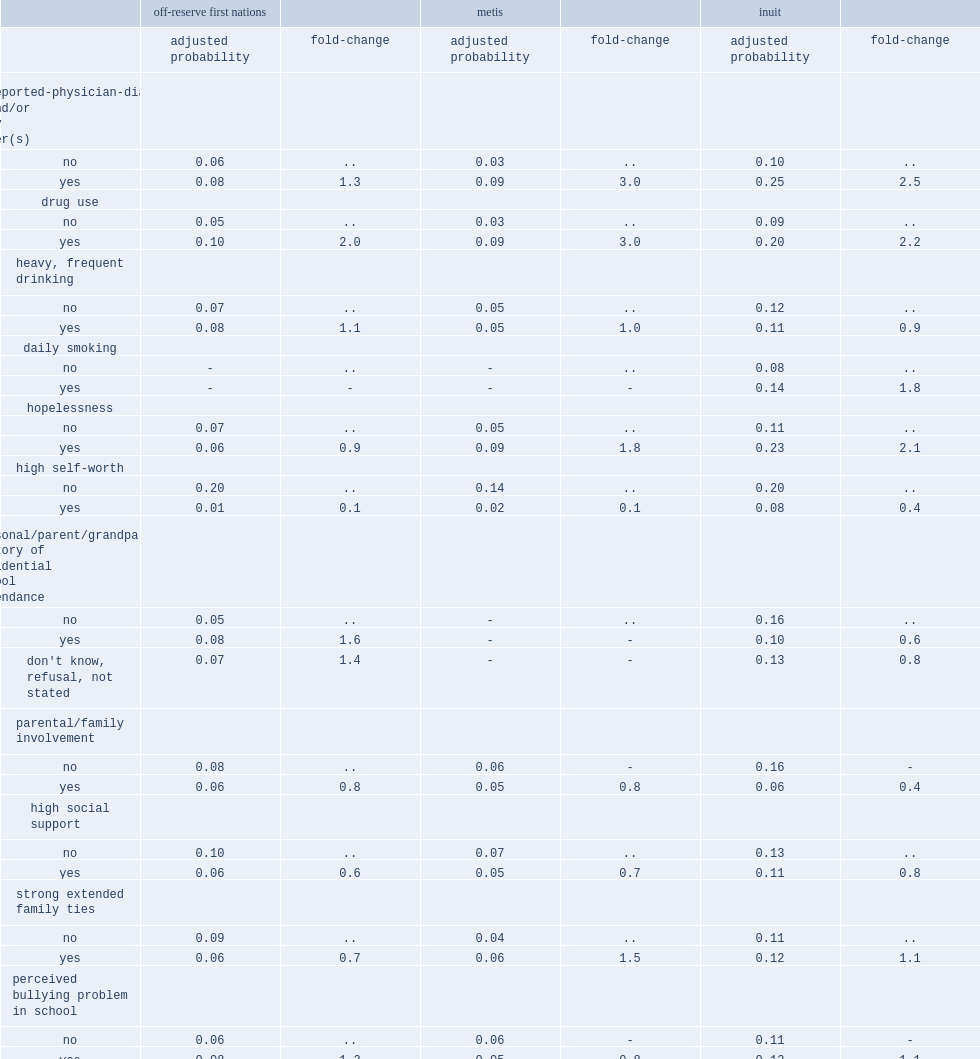What was the multiple relationship between metis who reported mood and/or anxiety disorders and those who did not? 3. What were the possbilities of metis who reported drug use had suicidal thoughts and those who did not respectively? 0.09 0.03. What were the possbilities of first nations who reported drug use had suicidal thoughts and those who did not respectively? 0.1 0.05. Among first nations,who were less likely to have suicidal thoughts,those who reported high self-worth or those who did not? Yes. What were the possbilities of first nations with high self-worth and those without respectively? 0.01 0.2. Among inuit,who were more likely to have suicidal thoughts,those who reported hopelessness or those who did not? Yes. What was the multiple relationship between off-reserve first nations with history of residential school attendance and those without? 1.6. Among inuit,who were less likely to have had suicidal thoughts,those reporting parental involvement or those who did not? Yes. Among off-reserve first nations,who were less likely to have had suicidal thoughts,those with strong extended family ties or those without? Yes. Among off-reserve first nations,who were more likely to have had suicidal thoughts,those who perceived a bullying environment in their secondary school or those who did not? Yes. Among off-reserve first nations,who had a lower prevalence of suicidal thoughts,those who were attending a post-secondary institution or those who were not attending any educational institution? Attending post-secondary institution. 